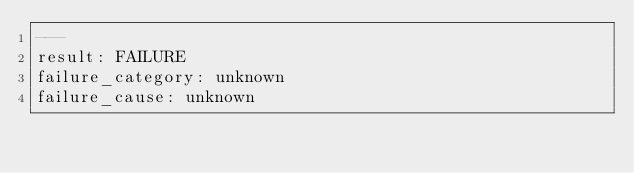Convert code to text. <code><loc_0><loc_0><loc_500><loc_500><_YAML_>---
result: FAILURE
failure_category: unknown
failure_cause: unknown</code> 